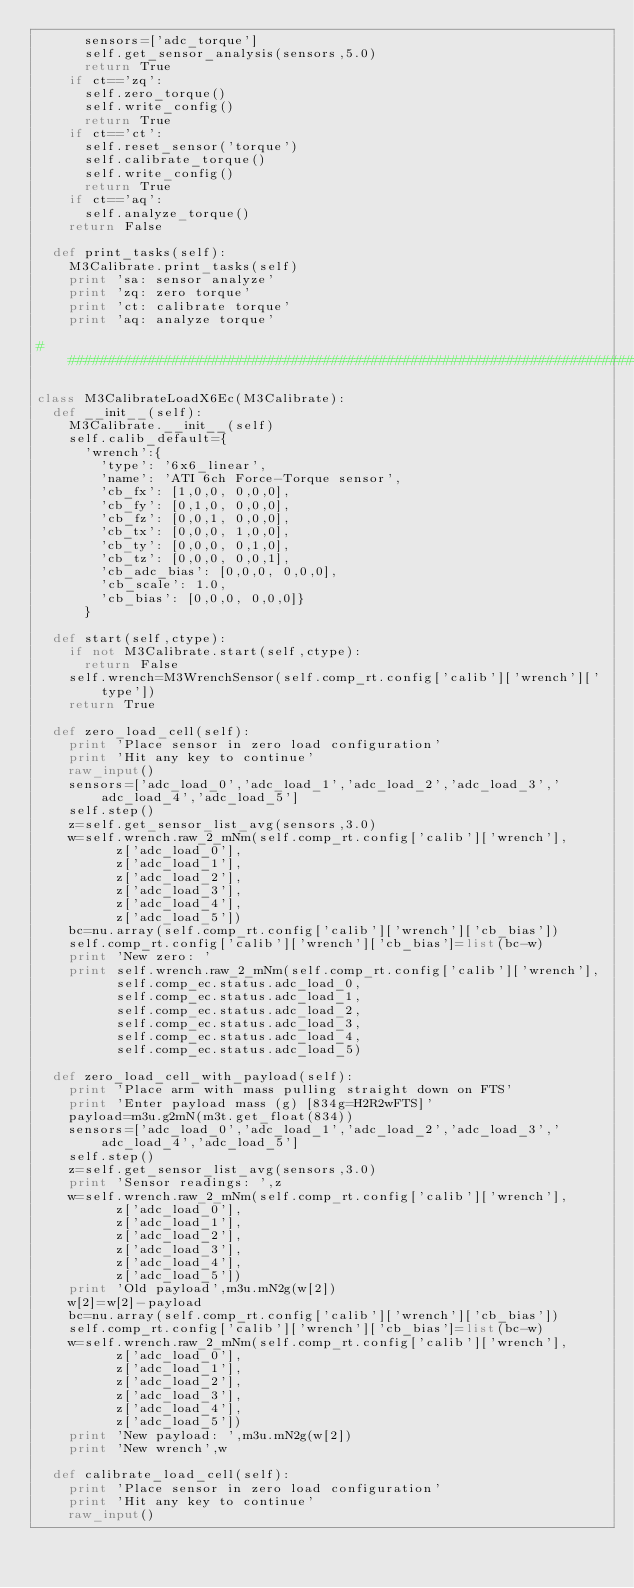<code> <loc_0><loc_0><loc_500><loc_500><_Python_>			sensors=['adc_torque']
			self.get_sensor_analysis(sensors,5.0)
			return True
		if ct=='zq':
			self.zero_torque()
			self.write_config()
			return True
		if ct=='ct':
			self.reset_sensor('torque')
			self.calibrate_torque()
			self.write_config()
			return True
		if ct=='aq':
			self.analyze_torque()
		return False
	
	def print_tasks(self):
		M3Calibrate.print_tasks(self)
		print 'sa: sensor analyze'
		print 'zq: zero torque'
		print 'ct: calibrate torque'
		print 'aq: analyze torque'
	
# ###############################################################################################################

class M3CalibrateLoadX6Ec(M3Calibrate):
	def __init__(self):
		M3Calibrate.__init__(self)
		self.calib_default={
			'wrench':{
				'type': '6x6_linear',
				'name': 'ATI 6ch Force-Torque sensor',
				'cb_fx': [1,0,0, 0,0,0],
				'cb_fy': [0,1,0, 0,0,0],
				'cb_fz': [0,0,1, 0,0,0],
				'cb_tx': [0,0,0, 1,0,0],
				'cb_ty': [0,0,0, 0,1,0],
				'cb_tz': [0,0,0, 0,0,1],
				'cb_adc_bias': [0,0,0, 0,0,0],
				'cb_scale': 1.0,
				'cb_bias': [0,0,0, 0,0,0]}
			}
	
	def start(self,ctype):
		if not M3Calibrate.start(self,ctype):
			return False
		self.wrench=M3WrenchSensor(self.comp_rt.config['calib']['wrench']['type'])
		return True

	def zero_load_cell(self):
		print 'Place sensor in zero load configuration'
		print 'Hit any key to continue'
		raw_input()
		sensors=['adc_load_0','adc_load_1','adc_load_2','adc_load_3','adc_load_4','adc_load_5']
		self.step()
		z=self.get_sensor_list_avg(sensors,3.0)
		w=self.wrench.raw_2_mNm(self.comp_rt.config['calib']['wrench'],
					z['adc_load_0'],
					z['adc_load_1'],
					z['adc_load_2'],
					z['adc_load_3'],
					z['adc_load_4'],
					z['adc_load_5'])
		bc=nu.array(self.comp_rt.config['calib']['wrench']['cb_bias'])
		self.comp_rt.config['calib']['wrench']['cb_bias']=list(bc-w)
		print 'New zero: '
		print self.wrench.raw_2_mNm(self.comp_rt.config['calib']['wrench'],
					self.comp_ec.status.adc_load_0,
					self.comp_ec.status.adc_load_1,
					self.comp_ec.status.adc_load_2,
					self.comp_ec.status.adc_load_3,
					self.comp_ec.status.adc_load_4,
					self.comp_ec.status.adc_load_5)
	
	def zero_load_cell_with_payload(self):
		print 'Place arm with mass pulling straight down on FTS'
		print 'Enter payload mass (g) [834g=H2R2wFTS]'
		payload=m3u.g2mN(m3t.get_float(834))
		sensors=['adc_load_0','adc_load_1','adc_load_2','adc_load_3','adc_load_4','adc_load_5']
		self.step()
		z=self.get_sensor_list_avg(sensors,3.0)
		print 'Sensor readings: ',z
		w=self.wrench.raw_2_mNm(self.comp_rt.config['calib']['wrench'],
					z['adc_load_0'],
					z['adc_load_1'],
					z['adc_load_2'],
					z['adc_load_3'],
					z['adc_load_4'],
					z['adc_load_5'])
		print 'Old payload',m3u.mN2g(w[2])
		w[2]=w[2]-payload
		bc=nu.array(self.comp_rt.config['calib']['wrench']['cb_bias'])
		self.comp_rt.config['calib']['wrench']['cb_bias']=list(bc-w)
		w=self.wrench.raw_2_mNm(self.comp_rt.config['calib']['wrench'],
					z['adc_load_0'],
					z['adc_load_1'],
					z['adc_load_2'],
					z['adc_load_3'],
					z['adc_load_4'],
					z['adc_load_5'])
		print 'New payload: ',m3u.mN2g(w[2])
		print 'New wrench',w
		
	def calibrate_load_cell(self):
		print 'Place sensor in zero load configuration'
		print 'Hit any key to continue'
		raw_input()</code> 